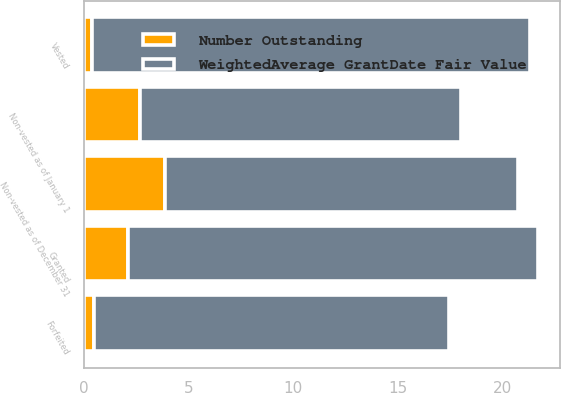Convert chart. <chart><loc_0><loc_0><loc_500><loc_500><stacked_bar_chart><ecel><fcel>Non-vested as of January 1<fcel>Granted<fcel>Vested<fcel>Forfeited<fcel>Non-vested as of December 31<nl><fcel>Number Outstanding<fcel>2.7<fcel>2.1<fcel>0.4<fcel>0.5<fcel>3.9<nl><fcel>WeightedAverage GrantDate Fair Value<fcel>15.34<fcel>19.59<fcel>20.92<fcel>16.94<fcel>16.85<nl></chart> 